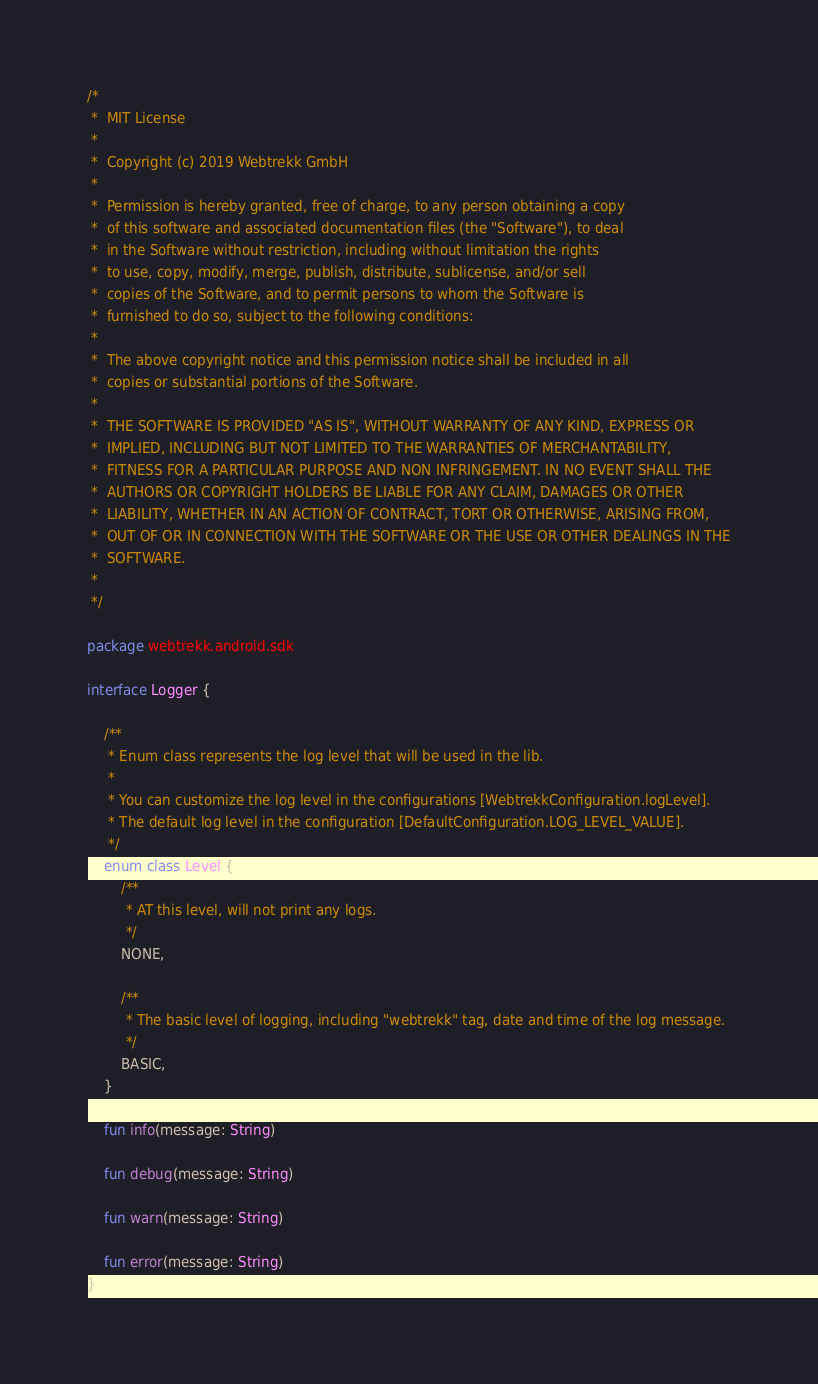Convert code to text. <code><loc_0><loc_0><loc_500><loc_500><_Kotlin_>/*
 *  MIT License
 *
 *  Copyright (c) 2019 Webtrekk GmbH
 *
 *  Permission is hereby granted, free of charge, to any person obtaining a copy
 *  of this software and associated documentation files (the "Software"), to deal
 *  in the Software without restriction, including without limitation the rights
 *  to use, copy, modify, merge, publish, distribute, sublicense, and/or sell
 *  copies of the Software, and to permit persons to whom the Software is
 *  furnished to do so, subject to the following conditions:
 *
 *  The above copyright notice and this permission notice shall be included in all
 *  copies or substantial portions of the Software.
 *
 *  THE SOFTWARE IS PROVIDED "AS IS", WITHOUT WARRANTY OF ANY KIND, EXPRESS OR
 *  IMPLIED, INCLUDING BUT NOT LIMITED TO THE WARRANTIES OF MERCHANTABILITY,
 *  FITNESS FOR A PARTICULAR PURPOSE AND NON INFRINGEMENT. IN NO EVENT SHALL THE
 *  AUTHORS OR COPYRIGHT HOLDERS BE LIABLE FOR ANY CLAIM, DAMAGES OR OTHER
 *  LIABILITY, WHETHER IN AN ACTION OF CONTRACT, TORT OR OTHERWISE, ARISING FROM,
 *  OUT OF OR IN CONNECTION WITH THE SOFTWARE OR THE USE OR OTHER DEALINGS IN THE
 *  SOFTWARE.
 *
 */

package webtrekk.android.sdk

interface Logger {

    /**
     * Enum class represents the log level that will be used in the lib.
     *
     * You can customize the log level in the configurations [WebtrekkConfiguration.logLevel].
     * The default log level in the configuration [DefaultConfiguration.LOG_LEVEL_VALUE].
     */
    enum class Level {
        /**
         * AT this level, will not print any logs.
         */
        NONE,

        /**
         * The basic level of logging, including "webtrekk" tag, date and time of the log message.
         */
        BASIC,
    }

    fun info(message: String)

    fun debug(message: String)

    fun warn(message: String)

    fun error(message: String)
}</code> 